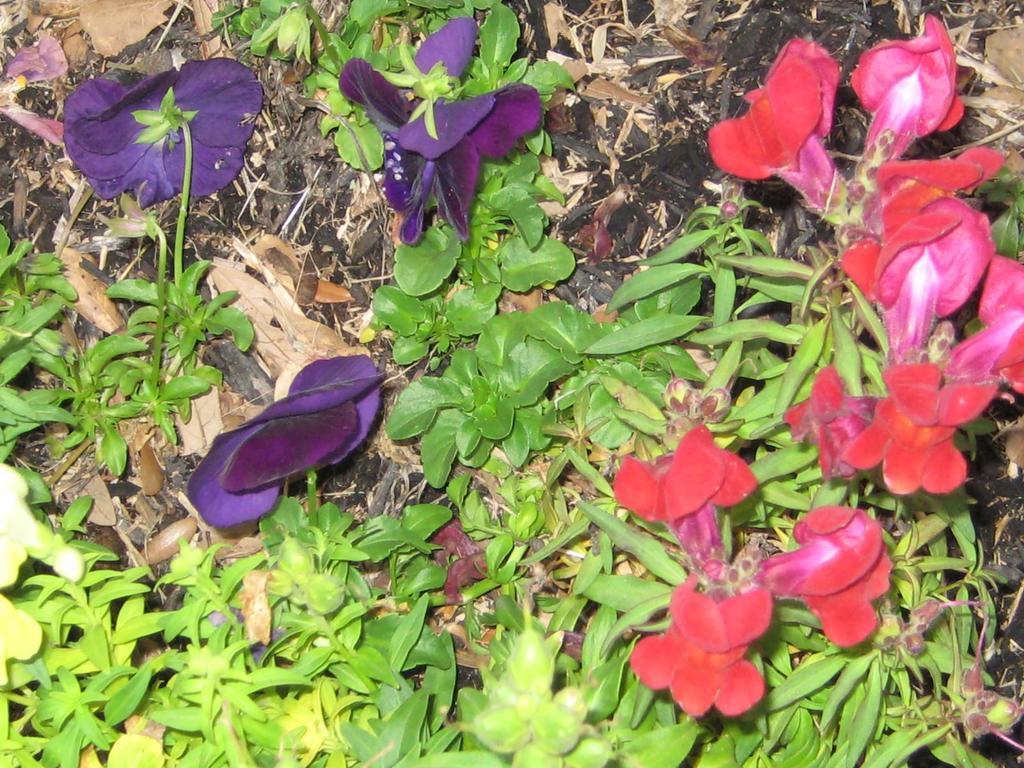Could you give a brief overview of what you see in this image? In this image we can see some flowers which are of pink red and violet color and there are some leaves. 